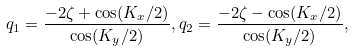<formula> <loc_0><loc_0><loc_500><loc_500>q _ { 1 } = \frac { - 2 \zeta + \cos ( K _ { x } / 2 ) } { \cos ( K _ { y } / 2 ) } , q _ { 2 } = \frac { - 2 \zeta - \cos ( K _ { x } / 2 ) } { \cos ( K _ { y } / 2 ) } ,</formula> 